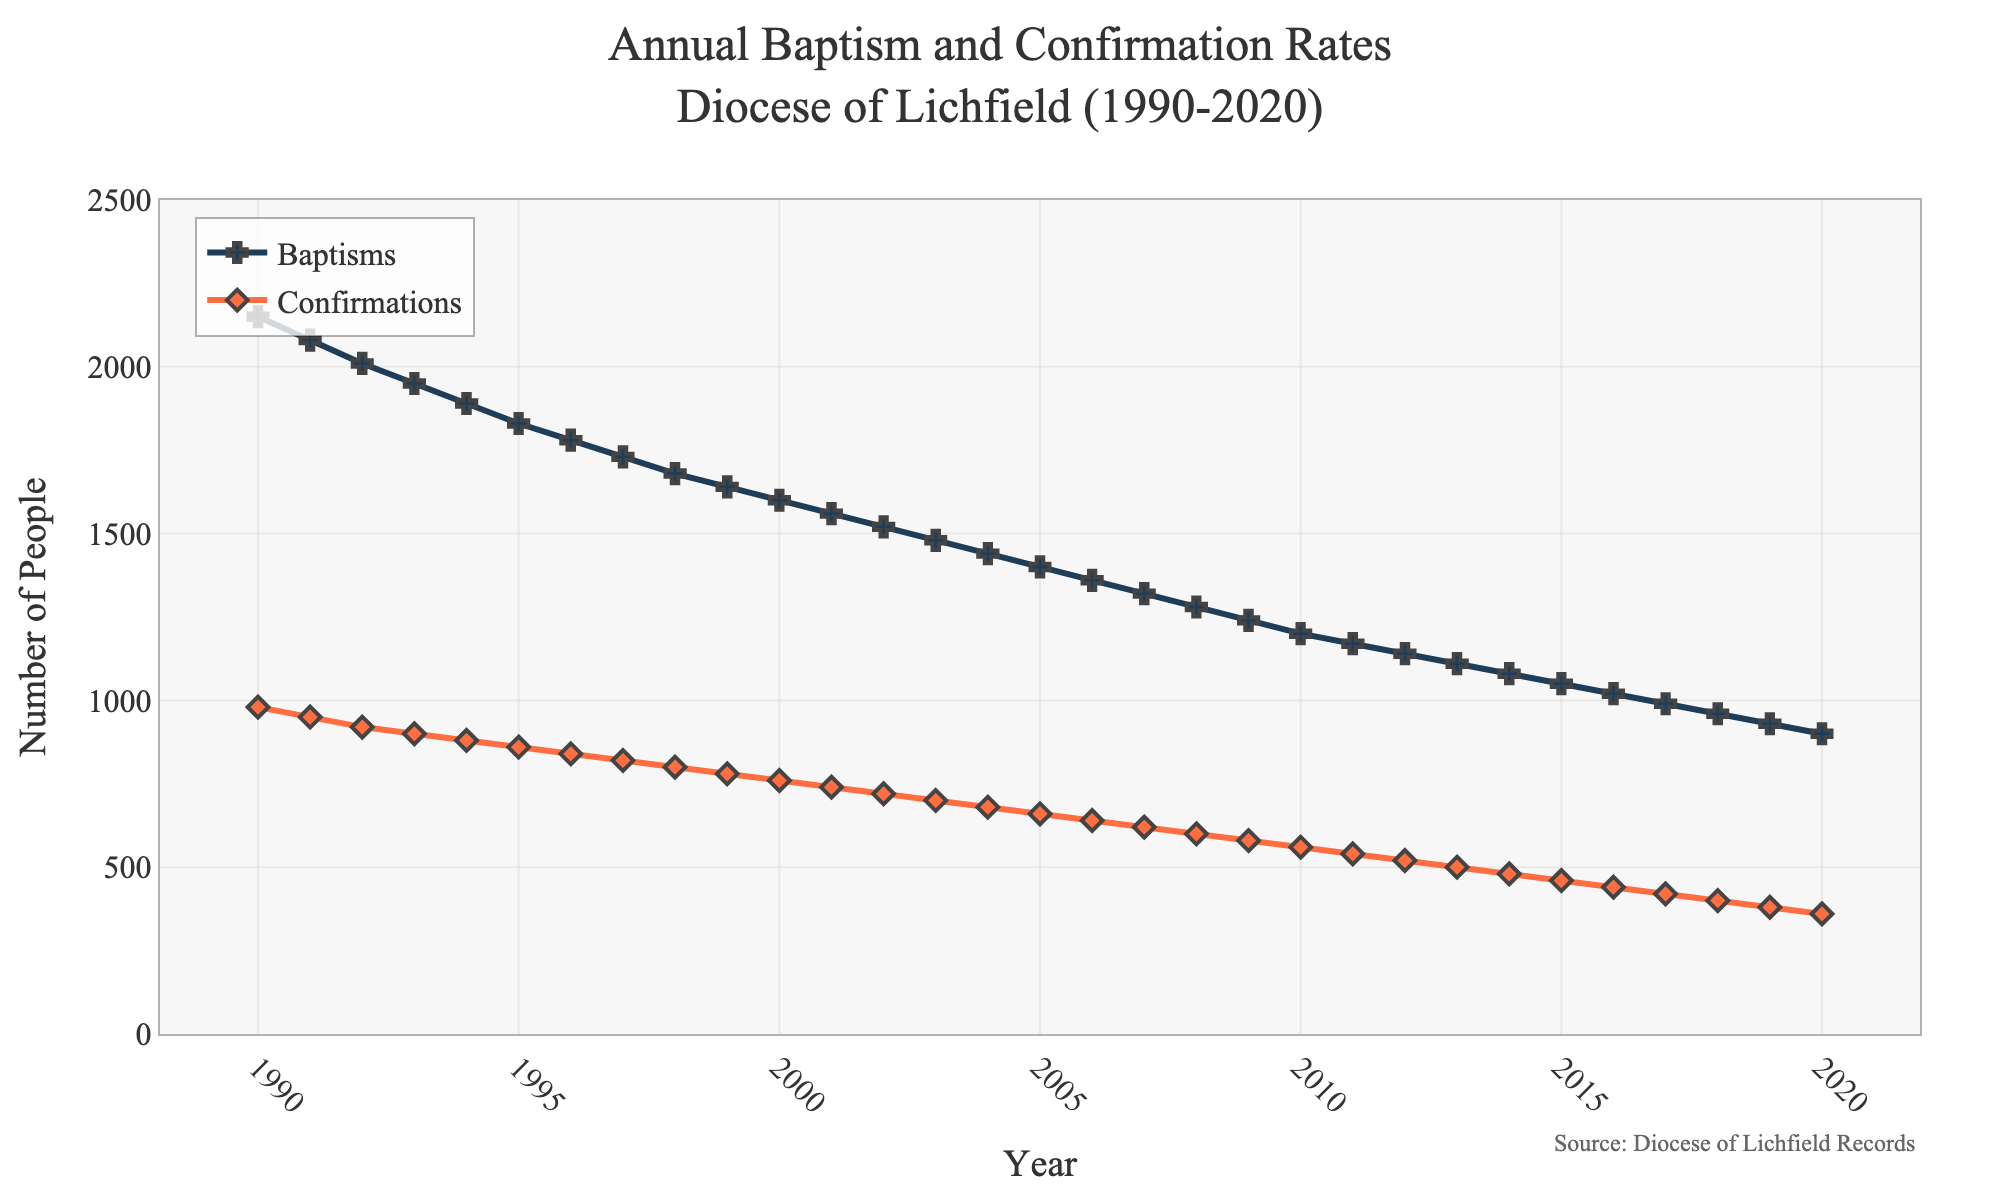What's the average number of baptisms in the years 1990 and 2020? Add the number of baptisms in 1990 (2150) and 2020 (900), then divide by 2: (2150 + 900) / 2 = 1525.
Answer: 1525 Which year saw the highest number of confirmations? By observing the figure, the year with the highest number of confirmations is 1990, with 980 confirmations.
Answer: 1990 How many more baptisms were there in 2005 compared to 2015? Subtract the number of baptisms in 2015 (1050) from the number in 2005 (1400): 1400 - 1050 = 350.
Answer: 350 In which decade did the overall trend show the most significant decline in the number of baptisms? By examining the slope of the lines, the 1990s show a more pronounced decline in baptisms compared to the later decades.
Answer: 1990s What is the difference in the number of confirmations between 1993 and 1998? Subtract the number of confirmations in 1998 (800) from the number in 1993 (900): 900 - 800 = 100.
Answer: 100 Which event, baptisms or confirmations, showed a steeper decline from 1990 to 2020? By visually comparing the slopes of the two lines, it is evident that baptisms show a steeper decline compared to confirmations.
Answer: Baptisms In what year did the number of baptisms first fall below 1500? Observe the figure and identify the year when the baptisms fall below 1500, which is 2002.
Answer: 2002 How does the number of confirmations in 2010 compare to the number of baptisms in the same year? By looking at the year 2010 on the figure, confirmations are at 560, while baptisms are at 1200. Baptisms are higher than confirmations.
Answer: Baptisms are higher What is the average annual decrease in the number of baptisms from 1990 to 2020? Calculate the total decrease in baptisms (2150 in 1990 to 900 in 2020) then divide by 30 years: (2150 - 900) / 30 ≈ 41.67.
Answer: 41.67 Compare the minimum number of baptisms and confirmations in the dataset. Which is lower and by how much? The minimum number of baptisms is 900 (2020) and confirmations is 360 (2020). The difference is 900 - 360 = 540.
Answer: Confirmations by 540 